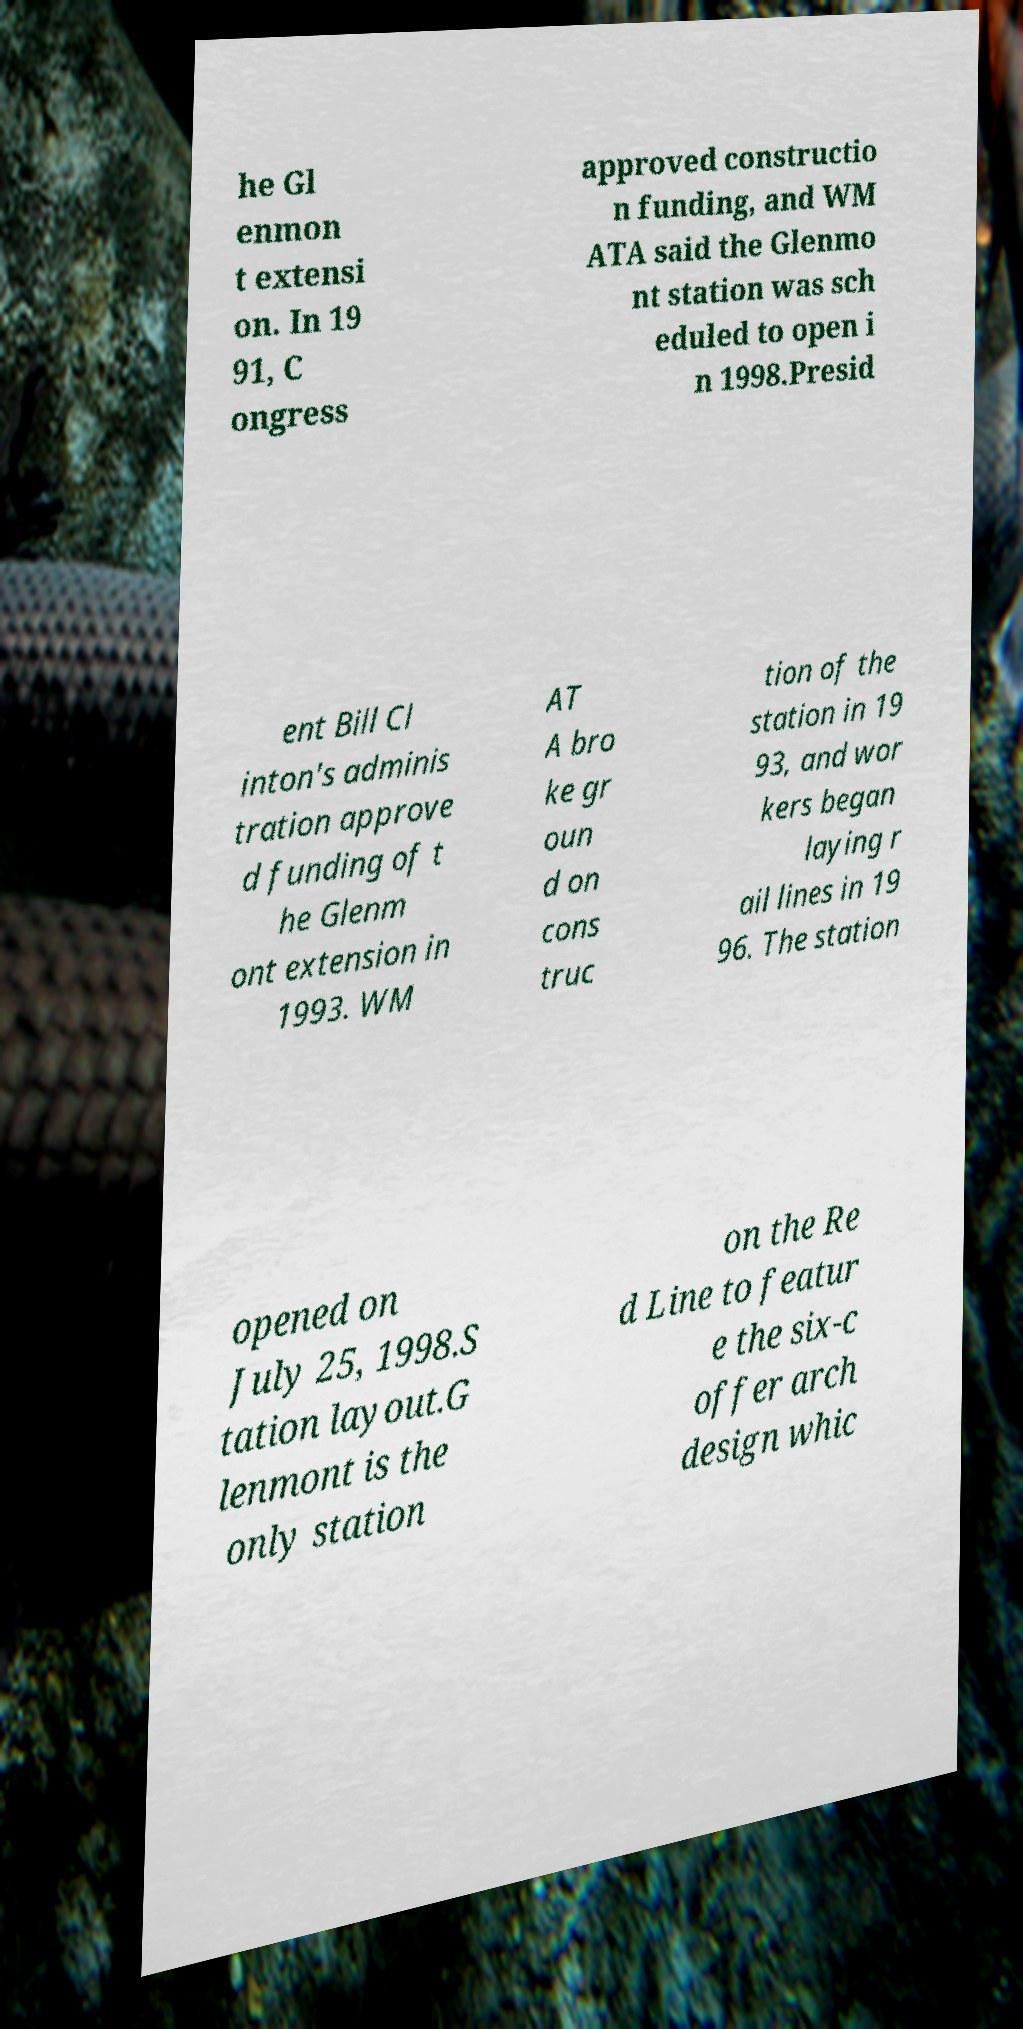Could you extract and type out the text from this image? he Gl enmon t extensi on. In 19 91, C ongress approved constructio n funding, and WM ATA said the Glenmo nt station was sch eduled to open i n 1998.Presid ent Bill Cl inton's adminis tration approve d funding of t he Glenm ont extension in 1993. WM AT A bro ke gr oun d on cons truc tion of the station in 19 93, and wor kers began laying r ail lines in 19 96. The station opened on July 25, 1998.S tation layout.G lenmont is the only station on the Re d Line to featur e the six-c offer arch design whic 